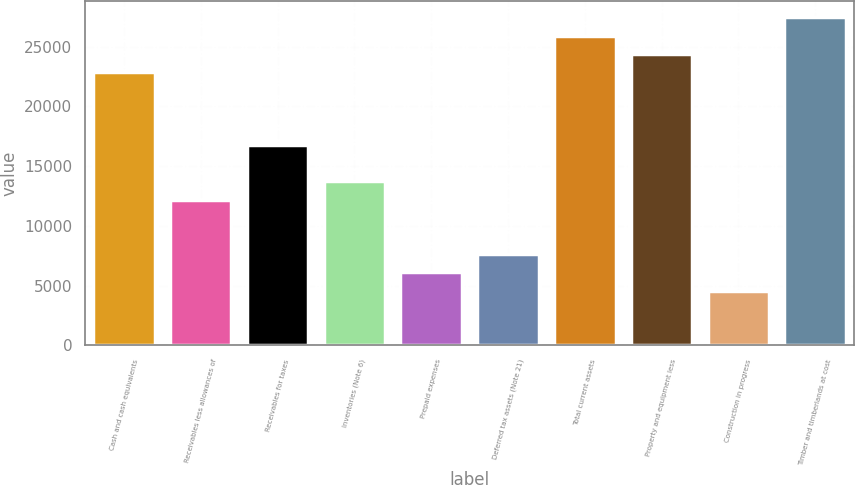Convert chart to OTSL. <chart><loc_0><loc_0><loc_500><loc_500><bar_chart><fcel>Cash and cash equivalents<fcel>Receivables less allowances of<fcel>Receivables for taxes<fcel>Inventories (Note 6)<fcel>Prepaid expenses<fcel>Deferred tax assets (Note 21)<fcel>Total current assets<fcel>Property and equipment less<fcel>Construction in progress<fcel>Timber and timberlands at cost<nl><fcel>22872<fcel>12201.2<fcel>16774.4<fcel>13725.6<fcel>6103.6<fcel>7628<fcel>25920.8<fcel>24396.4<fcel>4579.2<fcel>27445.2<nl></chart> 